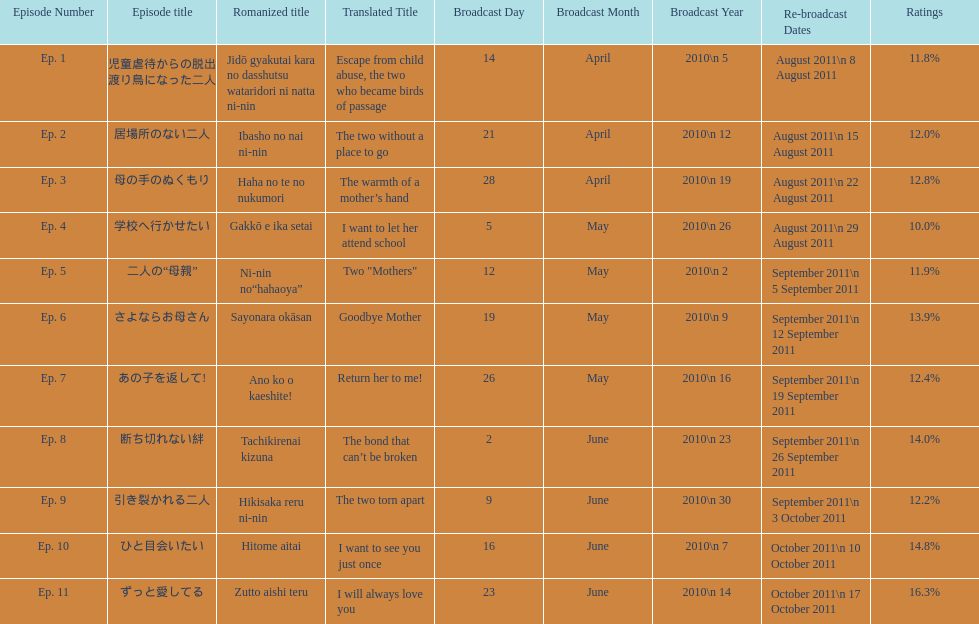What are all the titles the episodes of the mother tv series? 児童虐待からの脱出 渡り鳥になった二人, 居場所のない二人, 母の手のぬくもり, 学校へ行かせたい, 二人の“母親”, さよならお母さん, あの子を返して!, 断ち切れない絆, 引き裂かれる二人, ひと目会いたい, ずっと愛してる. What are all of the ratings for each of the shows? 11.8%, 12.0%, 12.8%, 10.0%, 11.9%, 13.9%, 12.4%, 14.0%, 12.2%, 14.8%, 16.3%. What is the highest score for ratings? 16.3%. What episode corresponds to that rating? ずっと愛してる. 